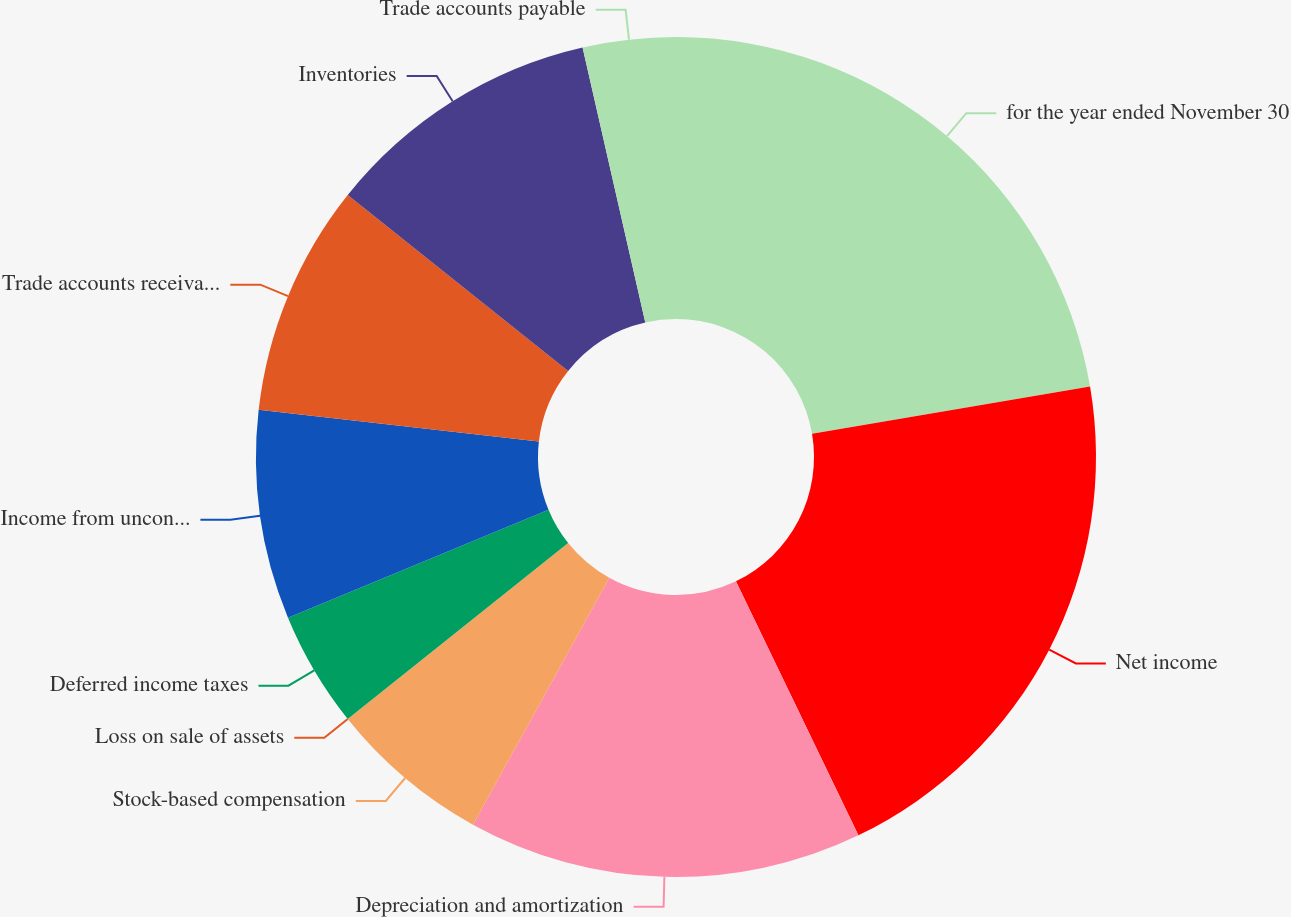Convert chart to OTSL. <chart><loc_0><loc_0><loc_500><loc_500><pie_chart><fcel>for the year ended November 30<fcel>Net income<fcel>Depreciation and amortization<fcel>Stock-based compensation<fcel>Loss on sale of assets<fcel>Deferred income taxes<fcel>Income from unconsolidated<fcel>Trade accounts receivable<fcel>Inventories<fcel>Trade accounts payable<nl><fcel>22.32%<fcel>20.53%<fcel>15.18%<fcel>6.25%<fcel>0.0%<fcel>4.47%<fcel>8.04%<fcel>8.93%<fcel>10.71%<fcel>3.57%<nl></chart> 